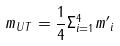Convert formula to latex. <formula><loc_0><loc_0><loc_500><loc_500>m _ { U T } = \frac { 1 } { 4 } \Sigma _ { i = 1 } ^ { 4 } { m ^ { \prime } } _ { i }</formula> 